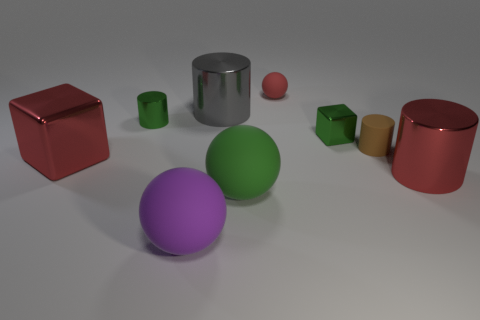Add 1 big cyan metal things. How many objects exist? 10 Subtract all brown cylinders. How many cylinders are left? 3 Subtract all red cubes. How many cubes are left? 1 Subtract all cubes. How many objects are left? 7 Add 4 green matte things. How many green matte things are left? 5 Add 1 large green rubber balls. How many large green rubber balls exist? 2 Subtract 1 red spheres. How many objects are left? 8 Subtract 2 spheres. How many spheres are left? 1 Subtract all blue cylinders. Subtract all purple spheres. How many cylinders are left? 4 Subtract all big matte blocks. Subtract all tiny red matte things. How many objects are left? 8 